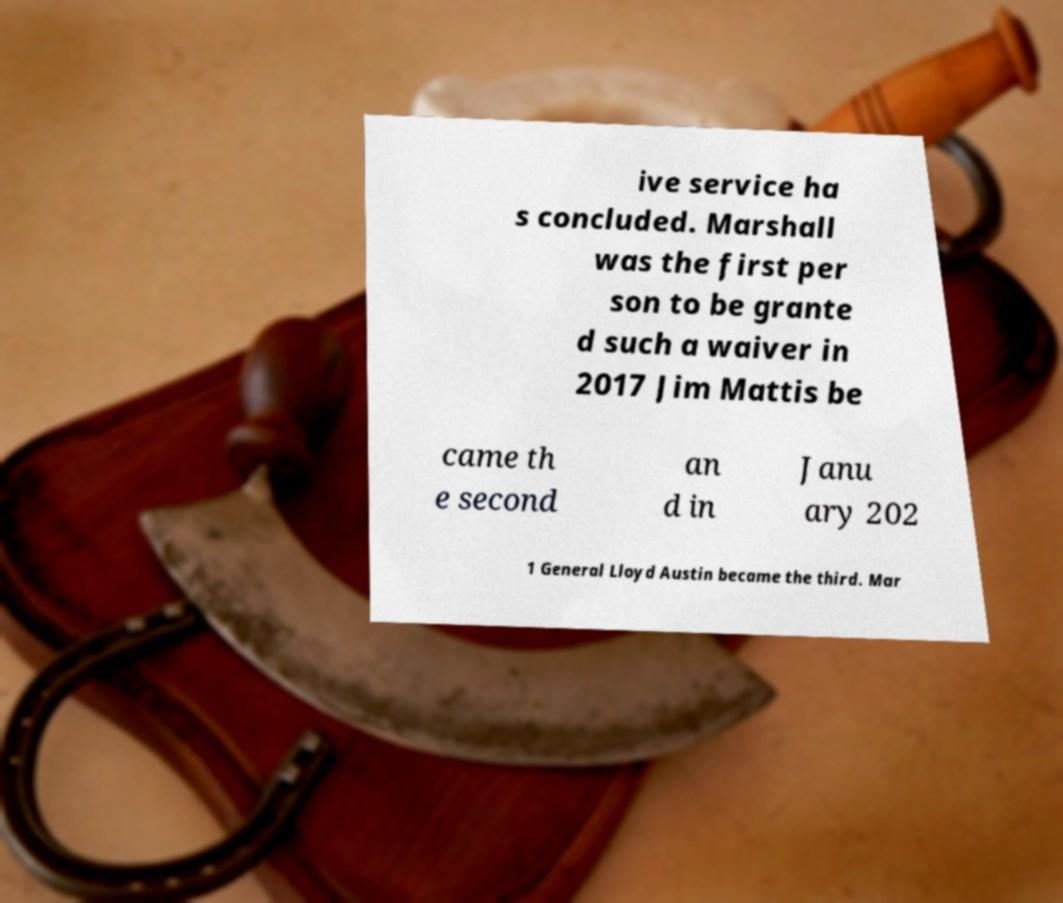Please read and relay the text visible in this image. What does it say? ive service ha s concluded. Marshall was the first per son to be grante d such a waiver in 2017 Jim Mattis be came th e second an d in Janu ary 202 1 General Lloyd Austin became the third. Mar 